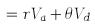Convert formula to latex. <formula><loc_0><loc_0><loc_500><loc_500>= r V _ { a } + \theta V _ { d }</formula> 